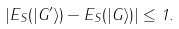<formula> <loc_0><loc_0><loc_500><loc_500>| E _ { S } ( | G ^ { \prime } \rangle ) - E _ { S } ( | G \rangle ) | \leq 1 .</formula> 